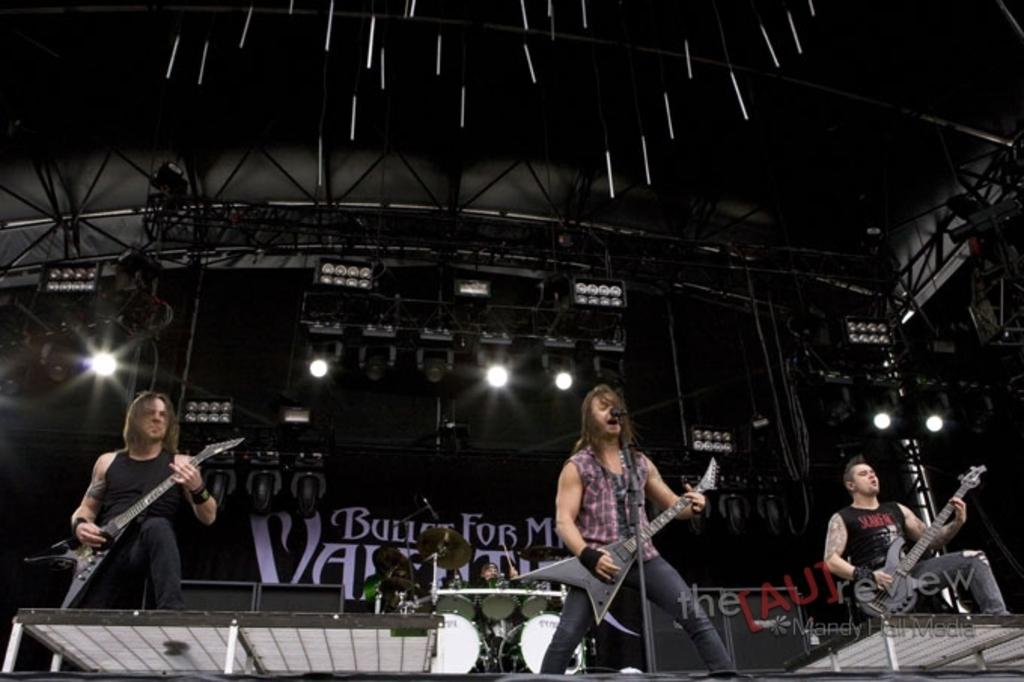How many people are in the image? There are three persons standing in the image. What are the three persons holding? The three persons are holding guitars. What is one person doing in the image? One person is singing. Can you describe the person playing a musical instrument? There is a person playing a musical instrument, but it is not specified which instrument. What can be seen in the background of the image? There is a focusing light in the background of the image. What type of account is being discussed by the three persons in the image? There is no mention of an account or any discussion in the image; the focus is on the people playing music. 